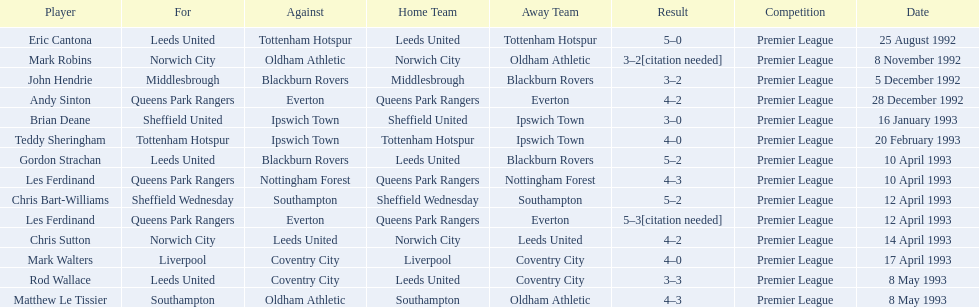Which team did liverpool play against? Coventry City. 